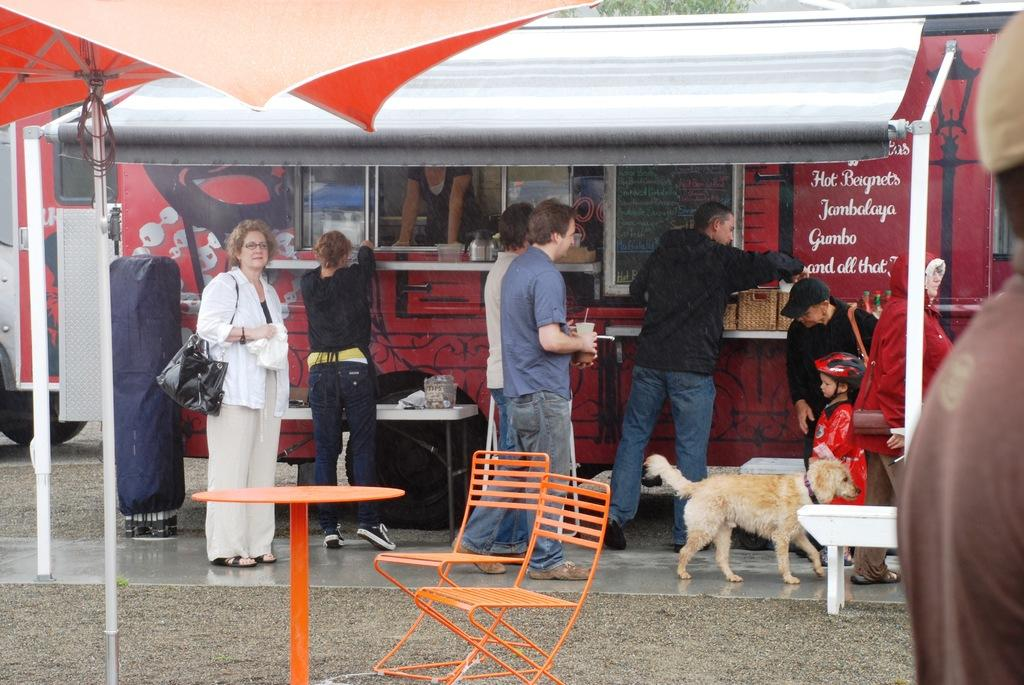Who is present in the image? There are persons in the image. Where are the persons located? The persons are standing at a food court. What furniture is visible in the foreground of the image? There are chairs and a table in the foreground of the image. What type of operation is being performed on the goose in the image? There is no goose present in the image, and therefore no operation is being performed. What is the coil used for in the image? There is no coil present in the image. 